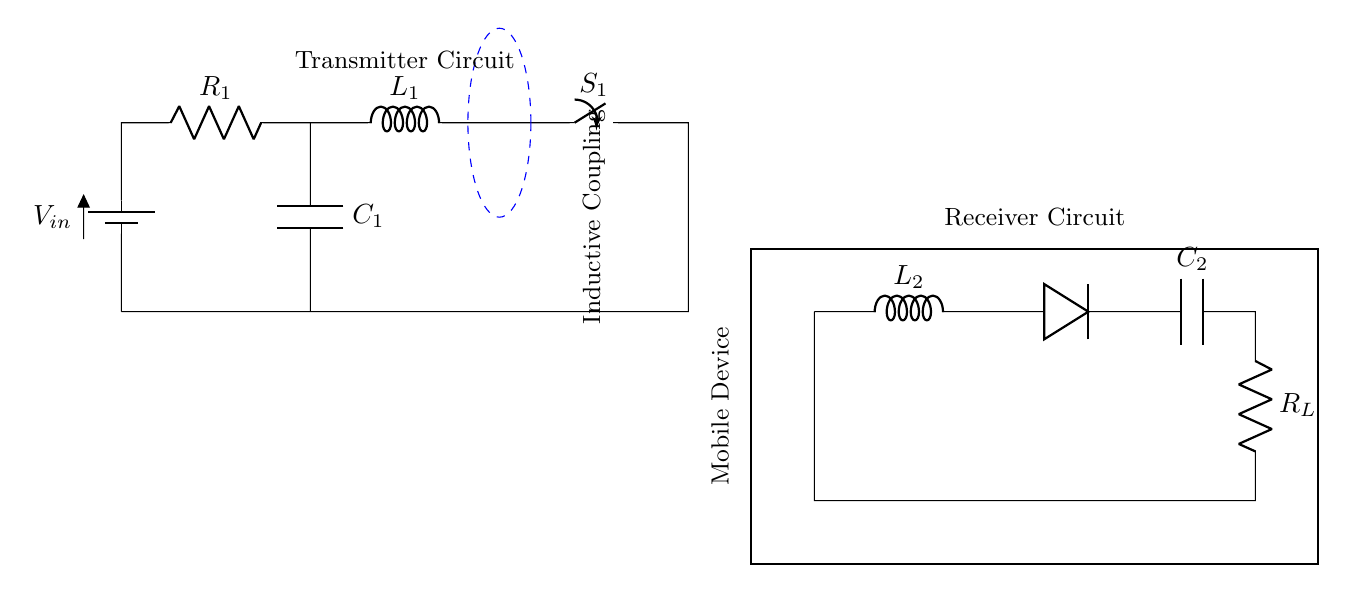What is the input voltage? The input voltage is labeled as V_in in the circuit diagram. This voltage is supplied from the battery, which is usually shown at the leftmost part of the circuit.
Answer: V_in What components make up the transmitter circuit? The transmitter circuit consists of a battery, a resistor labeled R_1, an inductor labeled L_1, a switch S_1, and a capacitor C_1. All these components are connected in series to create the transmitter.
Answer: Battery, R_1, L_1, S_1, C_1 What is the purpose of the inductor L_1 in this circuit? Inductor L_1 is used to create a magnetic field when current flows through it, facilitating the process of inductive coupling necessary for wireless charging. This is a key component for transferring energy to the secondary coil.
Answer: To create a magnetic field How is the receiver circuit connected in the circuit diagram? The receiver circuit is shown as a series of components including an inductor L_2, a diode (D), a capacitor C_2, and a load resistor R_L, connected sequentially. It connects to the output where the energy is received from the inductive coupling.
Answer: In series What is represented by the dashed blue arcs in the diagram? The dashed blue arcs represent the magnetic field generated by the primary coil (transmitter). This visual indicates how the energy is transmitted wirelessly to the secondary coil (receiver).
Answer: Magnetic field What does the switch S_1 do in this circuit? Switch S_1 controls the current flow through the primary circuit. When the switch is closed, it allows current to flow, generating the magnetic field necessary for the power transfer.
Answer: Controls current flow 